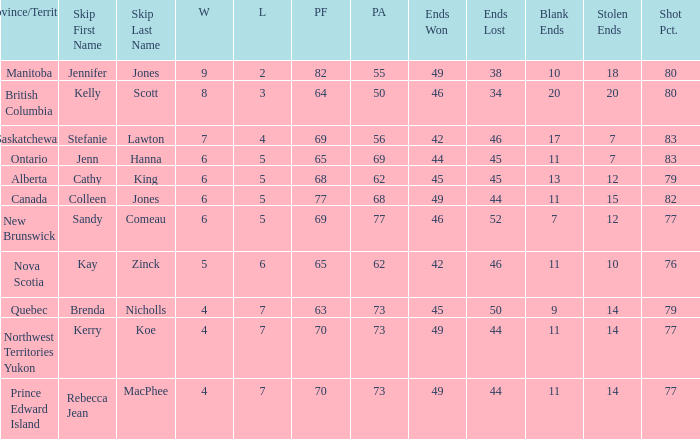What is the PA when the skip is Colleen Jones? 68.0. 